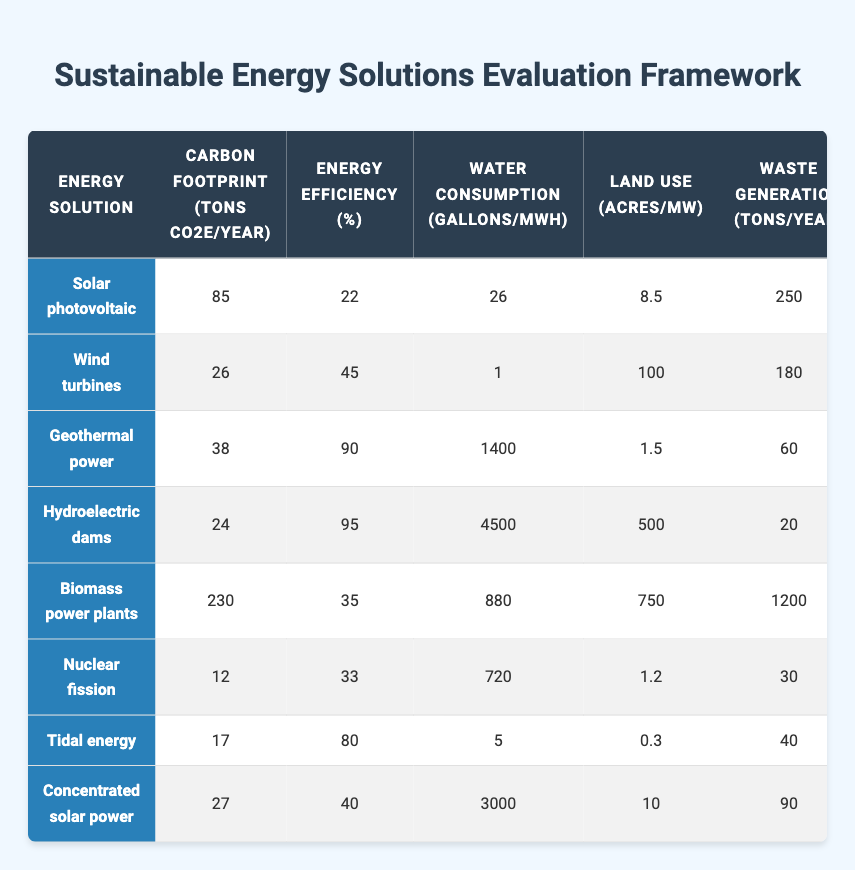What is the carbon footprint of wind turbines? The carbon footprint is listed in the row corresponding to wind turbines under the "Carbon footprint (tons CO2e/year)" column. The value is 26 tons CO2e/year.
Answer: 26 Which energy solution has the highest energy efficiency? By examining the "Energy efficiency (%)" column, geothermal power has the highest efficiency at 90%.
Answer: 90 What is the average water consumption of the energy solutions? Summing all the water consumption values: (26 + 1 + 1400 + 4500 + 880 + 720 + 5 + 3000) = 10332 gallons/MWh. There are 8 solutions, so the average is 10332/8 = 1291.5 gallons/MWh.
Answer: 1291.5 Is the recyclability of components for solar photovoltaic greater than for nuclear fission? Comparing the "Recyclability of components (%)" column, solar photovoltaic has a recyclability of 95%, while nuclear fission has 40%. Since 95 is greater than 40, the answer is yes.
Answer: Yes Which energy solution has the lowest land use? Looking at the "Land use (acres/MW)" column, tidal energy has the lowest value at 0.3 acres/MW.
Answer: 0.3 What is the difference in carbon footprint between biomass power plants and nuclear fission? The carbon footprint of biomass power plants is 230 tons CO2e/year and for nuclear fission, it is 12 tons CO2e/year. The difference is 230 - 12 = 218 tons CO2e/year.
Answer: 218 How many energy solutions have a biodiversity impact score of 6 or higher? Checking the "Biodiversity impact (scale 1-10)" column, the solutions with scores of 6 or more are wind turbines (6), hydroelectric dams (8), and biomass power plants (7), totaling 3 solutions.
Answer: 3 What is the total waste generation for solar photovoltaic and concentrated solar power? For solar photovoltaic, the waste generation is 250 tons/year, and for concentrated solar power, it is 90 tons/year. The total waste generation is 250 + 90 = 340 tons/year.
Answer: 340 